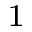Convert formula to latex. <formula><loc_0><loc_0><loc_500><loc_500>^ { 1 }</formula> 